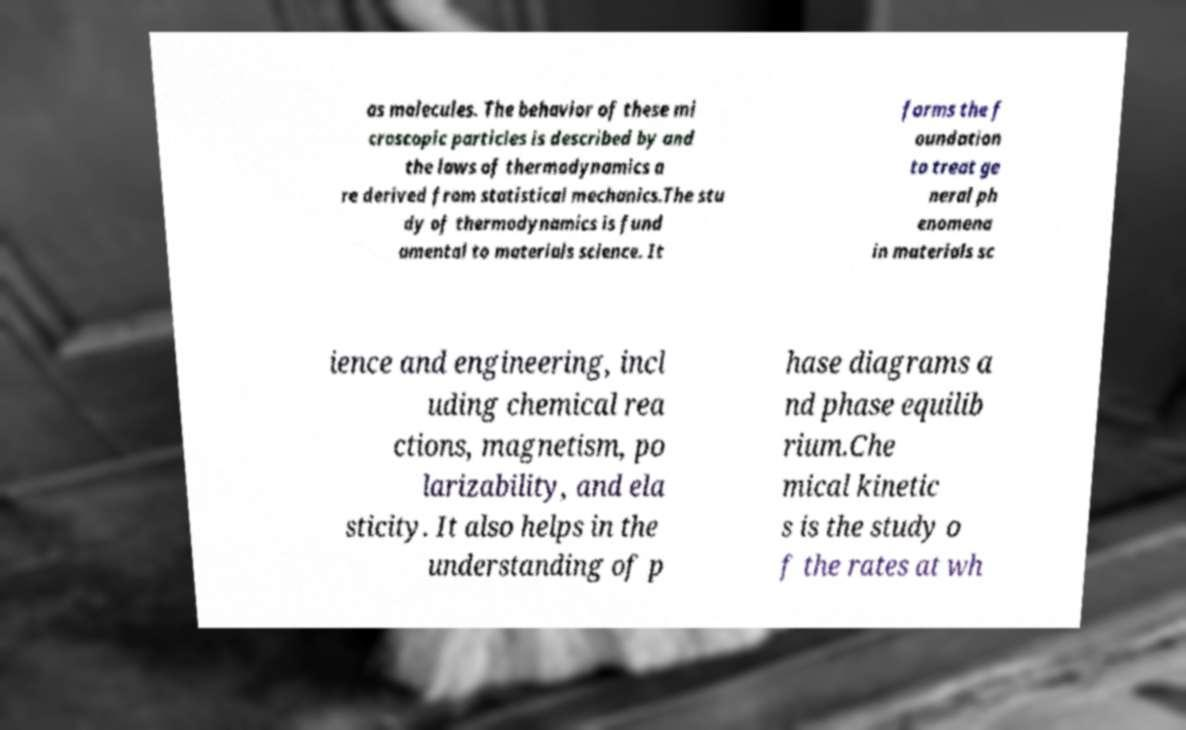For documentation purposes, I need the text within this image transcribed. Could you provide that? as molecules. The behavior of these mi croscopic particles is described by and the laws of thermodynamics a re derived from statistical mechanics.The stu dy of thermodynamics is fund amental to materials science. It forms the f oundation to treat ge neral ph enomena in materials sc ience and engineering, incl uding chemical rea ctions, magnetism, po larizability, and ela sticity. It also helps in the understanding of p hase diagrams a nd phase equilib rium.Che mical kinetic s is the study o f the rates at wh 